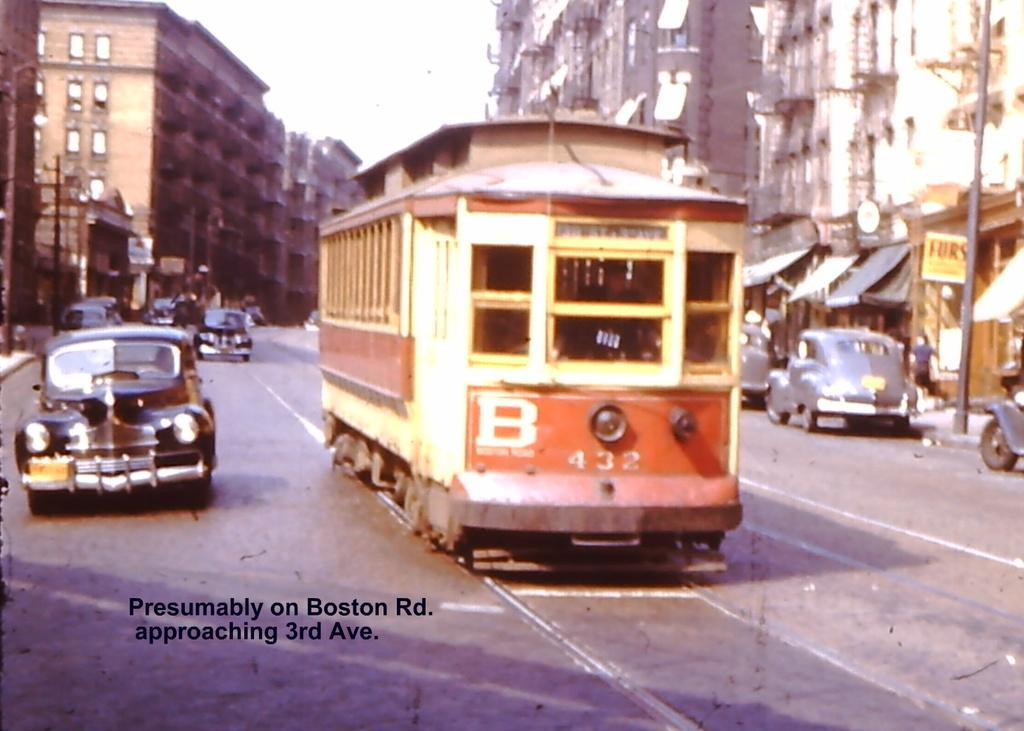<image>
Provide a brief description of the given image. A trolley, the caption says it is presumably on Boston Rd. 